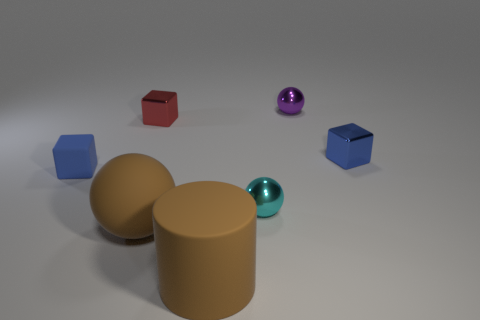What is the size of the metal cube that is the same color as the matte cube?
Offer a terse response. Small. What is the color of the tiny metal cube that is left of the small blue block that is to the right of the brown object right of the big matte ball?
Provide a short and direct response. Red. Is the cylinder made of the same material as the blue cube behind the blue matte cube?
Your answer should be compact. No. What is the small red thing made of?
Give a very brief answer. Metal. What is the material of the other tiny block that is the same color as the small rubber block?
Ensure brevity in your answer.  Metal. What number of other things are made of the same material as the big brown cylinder?
Make the answer very short. 2. What is the shape of the object that is both on the left side of the large brown matte cylinder and in front of the small cyan metal object?
Provide a short and direct response. Sphere. What color is the large cylinder that is the same material as the big brown sphere?
Your answer should be very brief. Brown. Is the number of large matte balls right of the blue metallic cube the same as the number of red rubber spheres?
Provide a short and direct response. Yes. The object that is the same size as the rubber ball is what shape?
Offer a very short reply. Cylinder. 